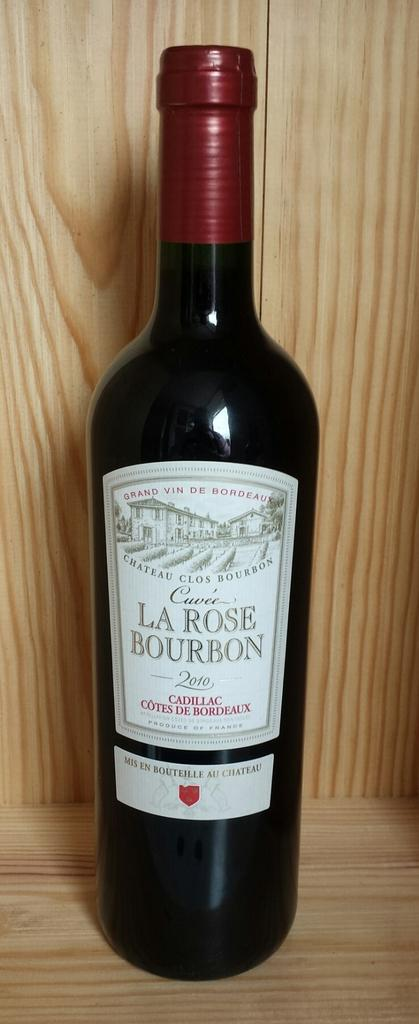<image>
Render a clear and concise summary of the photo. A bottle of La Rose Bourbon on a wooden shelf. 